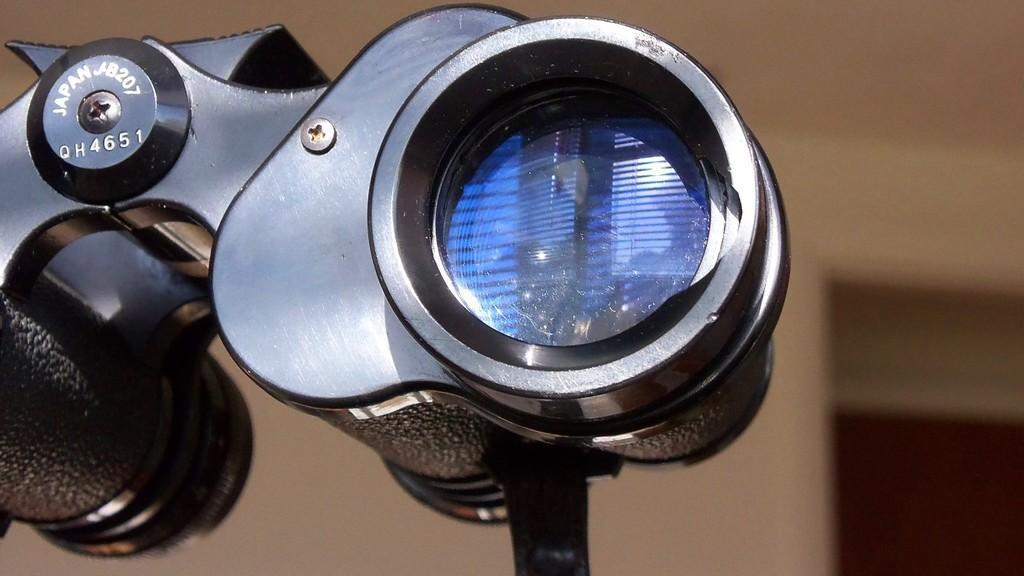How would you summarize this image in a sentence or two? In this image I can see a black colored object which looks like a binocular. I can see the blurry background which is brown in color. 